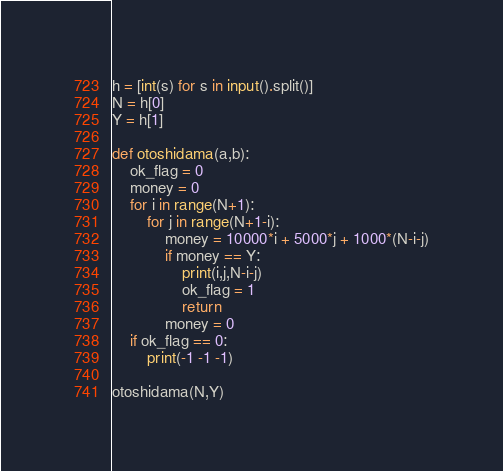Convert code to text. <code><loc_0><loc_0><loc_500><loc_500><_Python_>h = [int(s) for s in input().split()]
N = h[0]
Y = h[1]

def otoshidama(a,b):
	ok_flag = 0
	money = 0
	for i in range(N+1):
  		for j in range(N+1-i):
      		money = 10000*i + 5000*j + 1000*(N-i-j)
      		if money == Y:
        		print(i,j,N-i-j)
        		ok_flag = 1
        		return
      		money = 0 
	if ok_flag == 0:
  		print(-1 -1 -1)
  
otoshidama(N,Y)</code> 